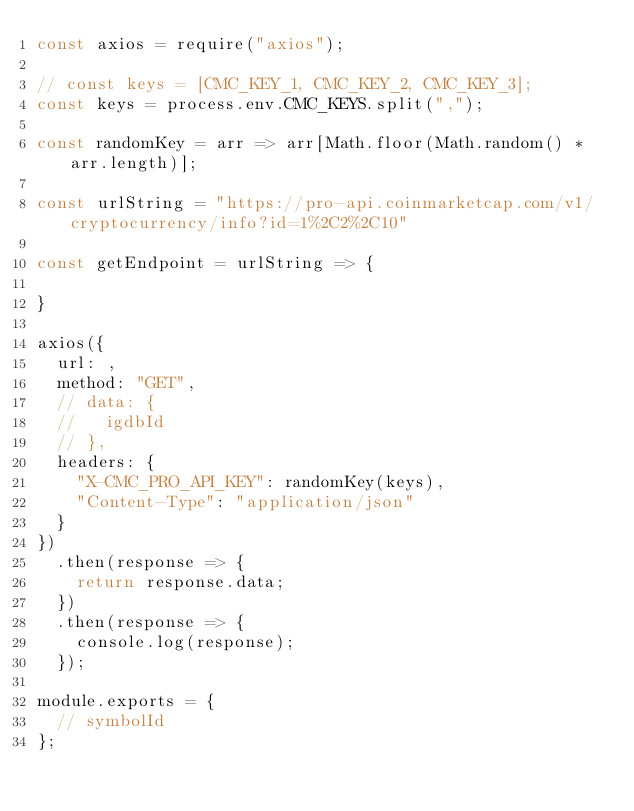Convert code to text. <code><loc_0><loc_0><loc_500><loc_500><_JavaScript_>const axios = require("axios");

// const keys = [CMC_KEY_1, CMC_KEY_2, CMC_KEY_3];
const keys = process.env.CMC_KEYS.split(",");

const randomKey = arr => arr[Math.floor(Math.random() * arr.length)];

const urlString = "https://pro-api.coinmarketcap.com/v1/cryptocurrency/info?id=1%2C2%2C10"

const getEndpoint = urlString => {
  
}

axios({
  url: ,
  method: "GET",
  // data: {
  //   igdbId
  // },
  headers: {
    "X-CMC_PRO_API_KEY": randomKey(keys),
    "Content-Type": "application/json"
  }
})
  .then(response => {
    return response.data;
  })
  .then(response => {
    console.log(response);
  });

module.exports = {
  // symbolId
};
</code> 